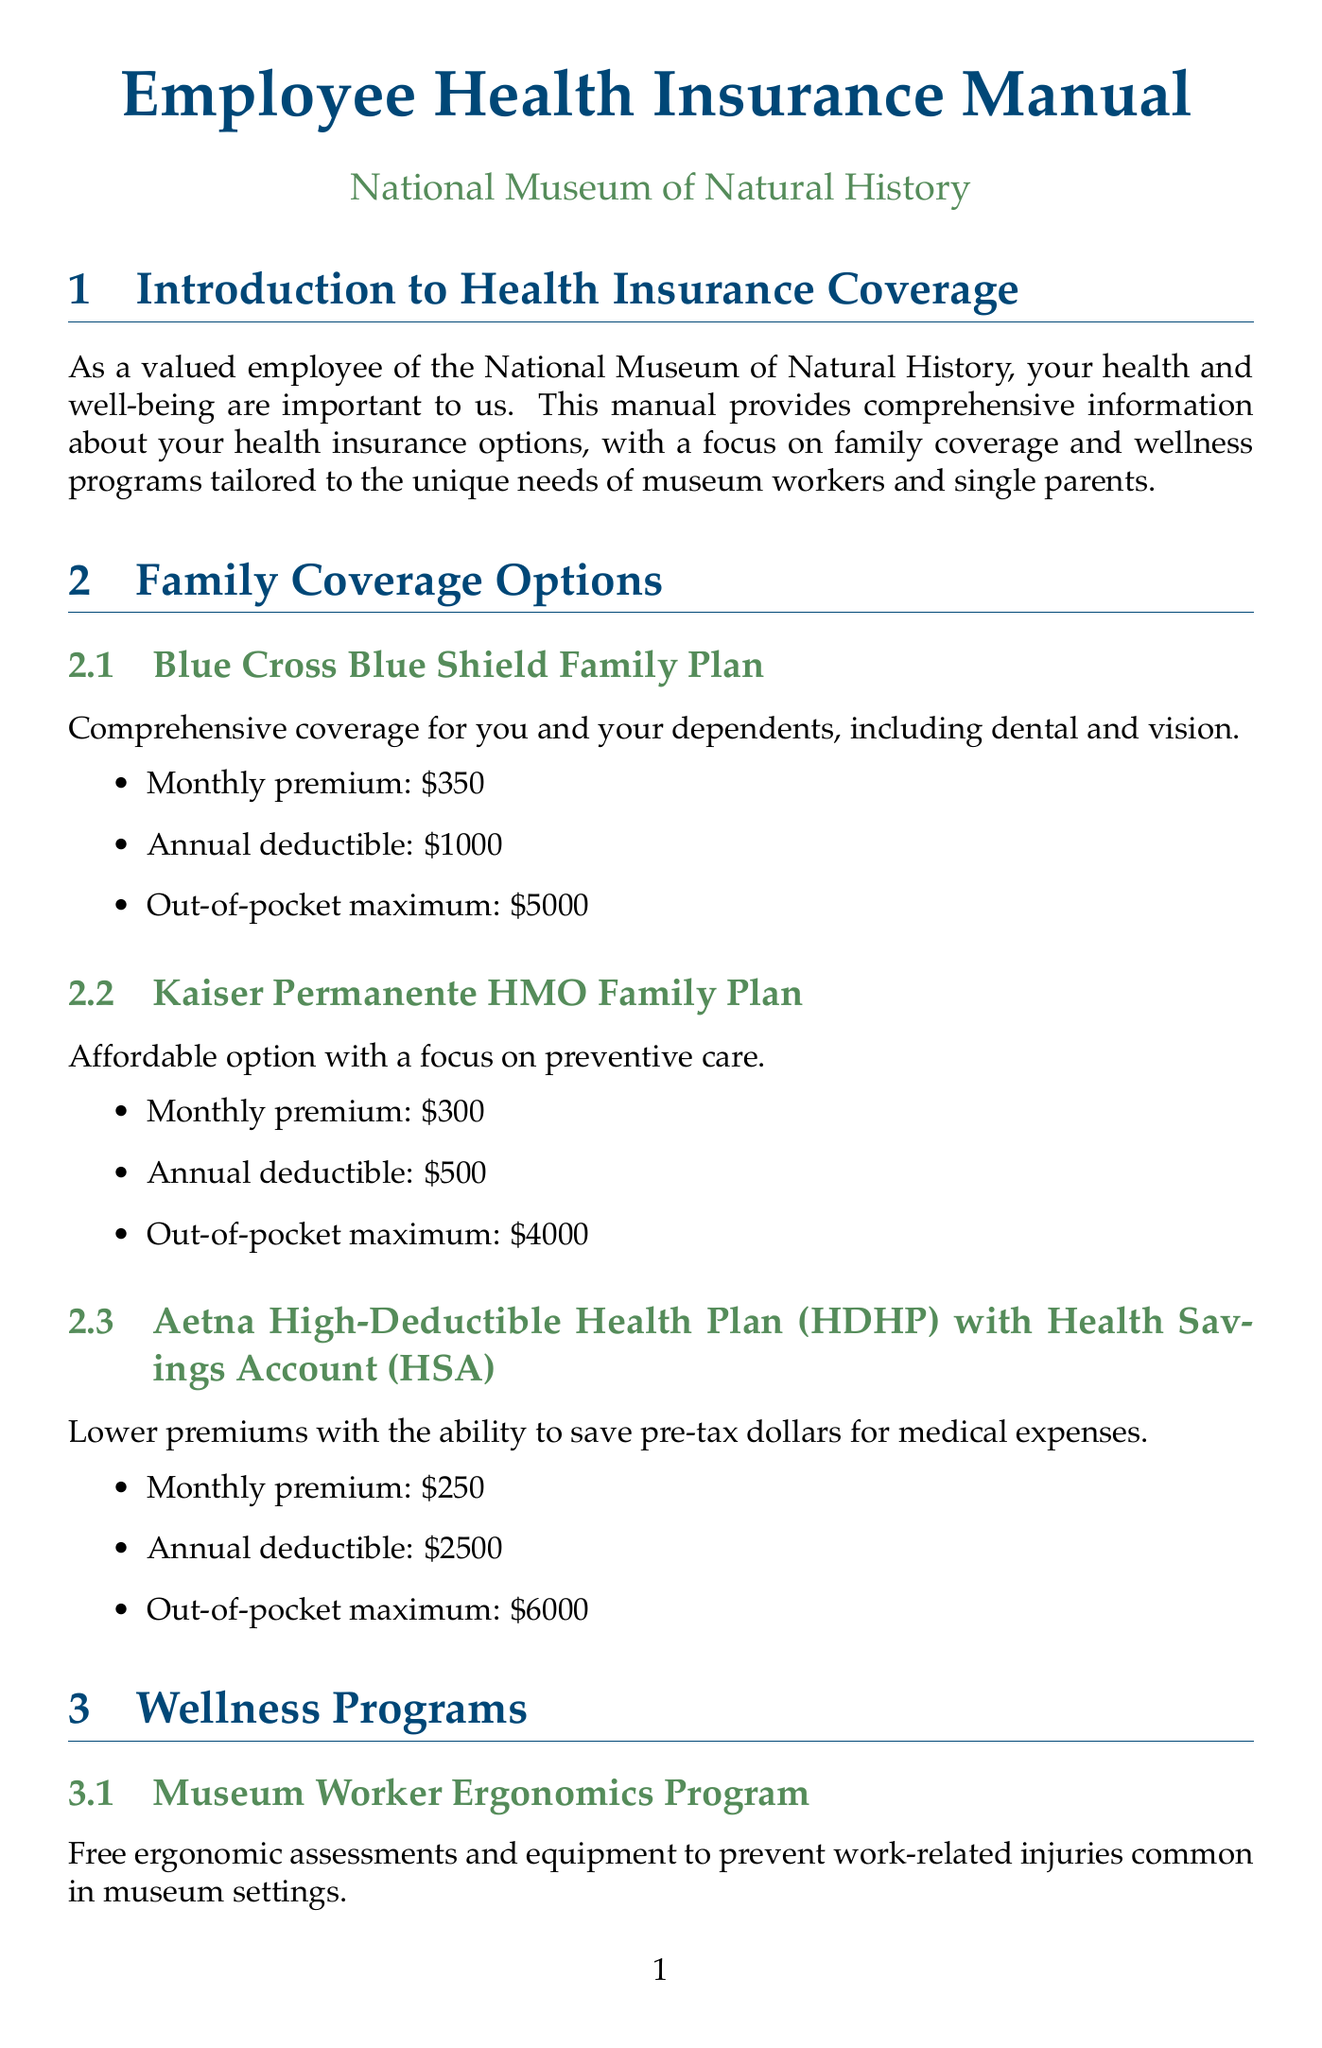What is the monthly premium for the Blue Cross Blue Shield Family Plan? The monthly premium for the Blue Cross Blue Shield Family Plan is specified in the document as $350.
Answer: $350 What is the out-of-pocket maximum for the Kaiser Permanente HMO Family Plan? The document states that the out-of-pocket maximum for the Kaiser Permanente HMO Family Plan is $4000.
Answer: $4000 What wellness program offers ergonomic assessments? The Museum Worker Ergonomics Program is mentioned in the document as offering free ergonomic assessments and equipment.
Answer: Museum Worker Ergonomics Program Which program provides reimbursement for fitness expenses? The Flexible Fitness Reimbursement program is highlighted for providing up to $500 annual reimbursement for fitness-related expenses.
Answer: Flexible Fitness Reimbursement What is the deductible amount for the Aetna HDHP plan? According to the document, the annual deductible for the Aetna High-Deductible Health Plan is $2500.
Answer: $2500 What services does the Employee Assistance Program (EAP) provide? The EAP provides confidential counseling and support services for personal or work-related issues, including child-rearing challenges and financial advice.
Answer: Counseling and support services When is the open enrollment period for health insurance? The open enrollment period is stated in the document as being from October 1st to November 15th each year.
Answer: October 1st to November 15th What benefit covers 100% of preventive care services? The document mentions that all health plans cover 100% of preventive care services.
Answer: Preventive care services What is the maximum amount one can set aside in the Dependent Care FSA per year? The document specifies that employees can set aside up to $5000 pre-tax per year in the Dependent Care FSA.
Answer: $5000 